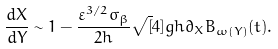Convert formula to latex. <formula><loc_0><loc_0><loc_500><loc_500>\frac { d X } { d Y } \sim 1 - \frac { \varepsilon ^ { 3 / 2 } \sigma _ { \beta } } { 2 h } \sqrt { [ } 4 ] { g h } \partial _ { X } B _ { \omega ( Y ) } ( t ) .</formula> 